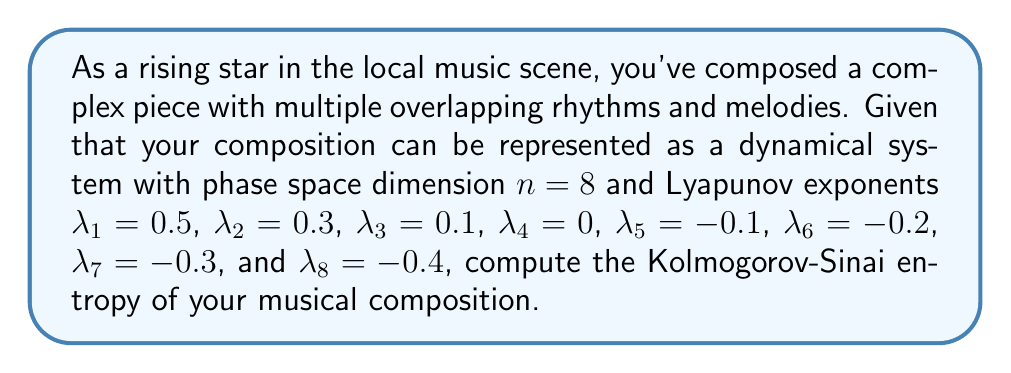Give your solution to this math problem. To compute the Kolmogorov-Sinai (KS) entropy of a dynamical system, we follow these steps:

1) The KS entropy is defined as the sum of all positive Lyapunov exponents:

   $$h_{KS} = \sum_{\lambda_i > 0} \lambda_i$$

2) In this case, we have three positive Lyapunov exponents:
   $\lambda_1 = 0.5$, $\lambda_2 = 0.3$, and $\lambda_3 = 0.1$

3) We sum these positive exponents:

   $$h_{KS} = 0.5 + 0.3 + 0.1$$

4) Performing the addition:

   $$h_{KS} = 0.9$$

The KS entropy value of 0.9 indicates the rate of information production or the degree of unpredictability in your musical composition. A higher value suggests more complexity and unpredictability, which aligns with your reputation for innovative sound.
Answer: 0.9 